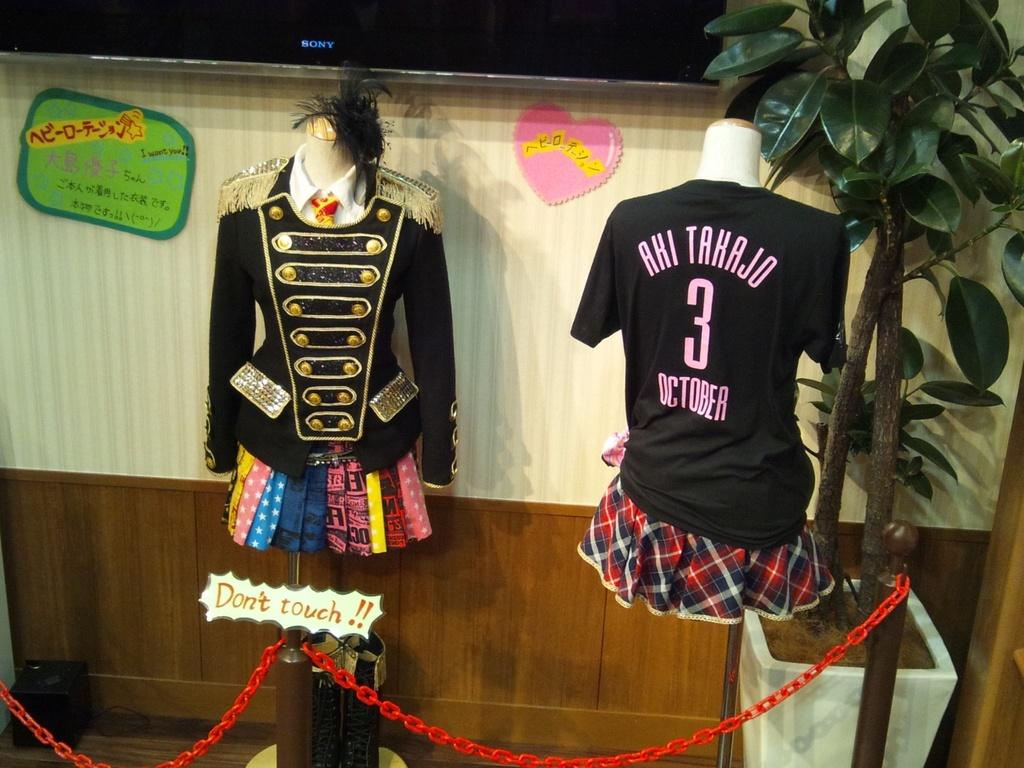<image>
Create a compact narrative representing the image presented. The back of a shirt says Aki Takajo 3 October. 